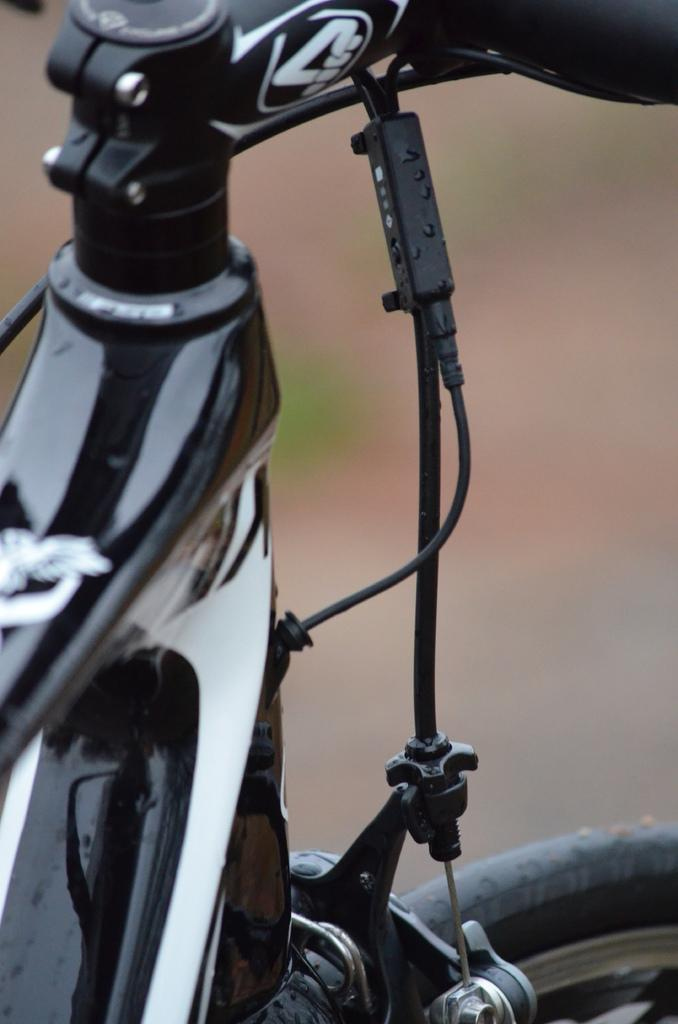What is the main subject of the image? The main subject of the image is a bicycle. What color is the bicycle? The bicycle is black in color. Can you describe the background of the image? The background of the image is blurry. What type of glass is used to make the wire fence in the image? There is no wire fence or glass present in the image; it features a black bicycle with a blurry background. 